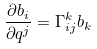<formula> <loc_0><loc_0><loc_500><loc_500>\frac { \partial b _ { i } } { \partial q ^ { j } } = \Gamma _ { i j } ^ { k } b _ { k }</formula> 